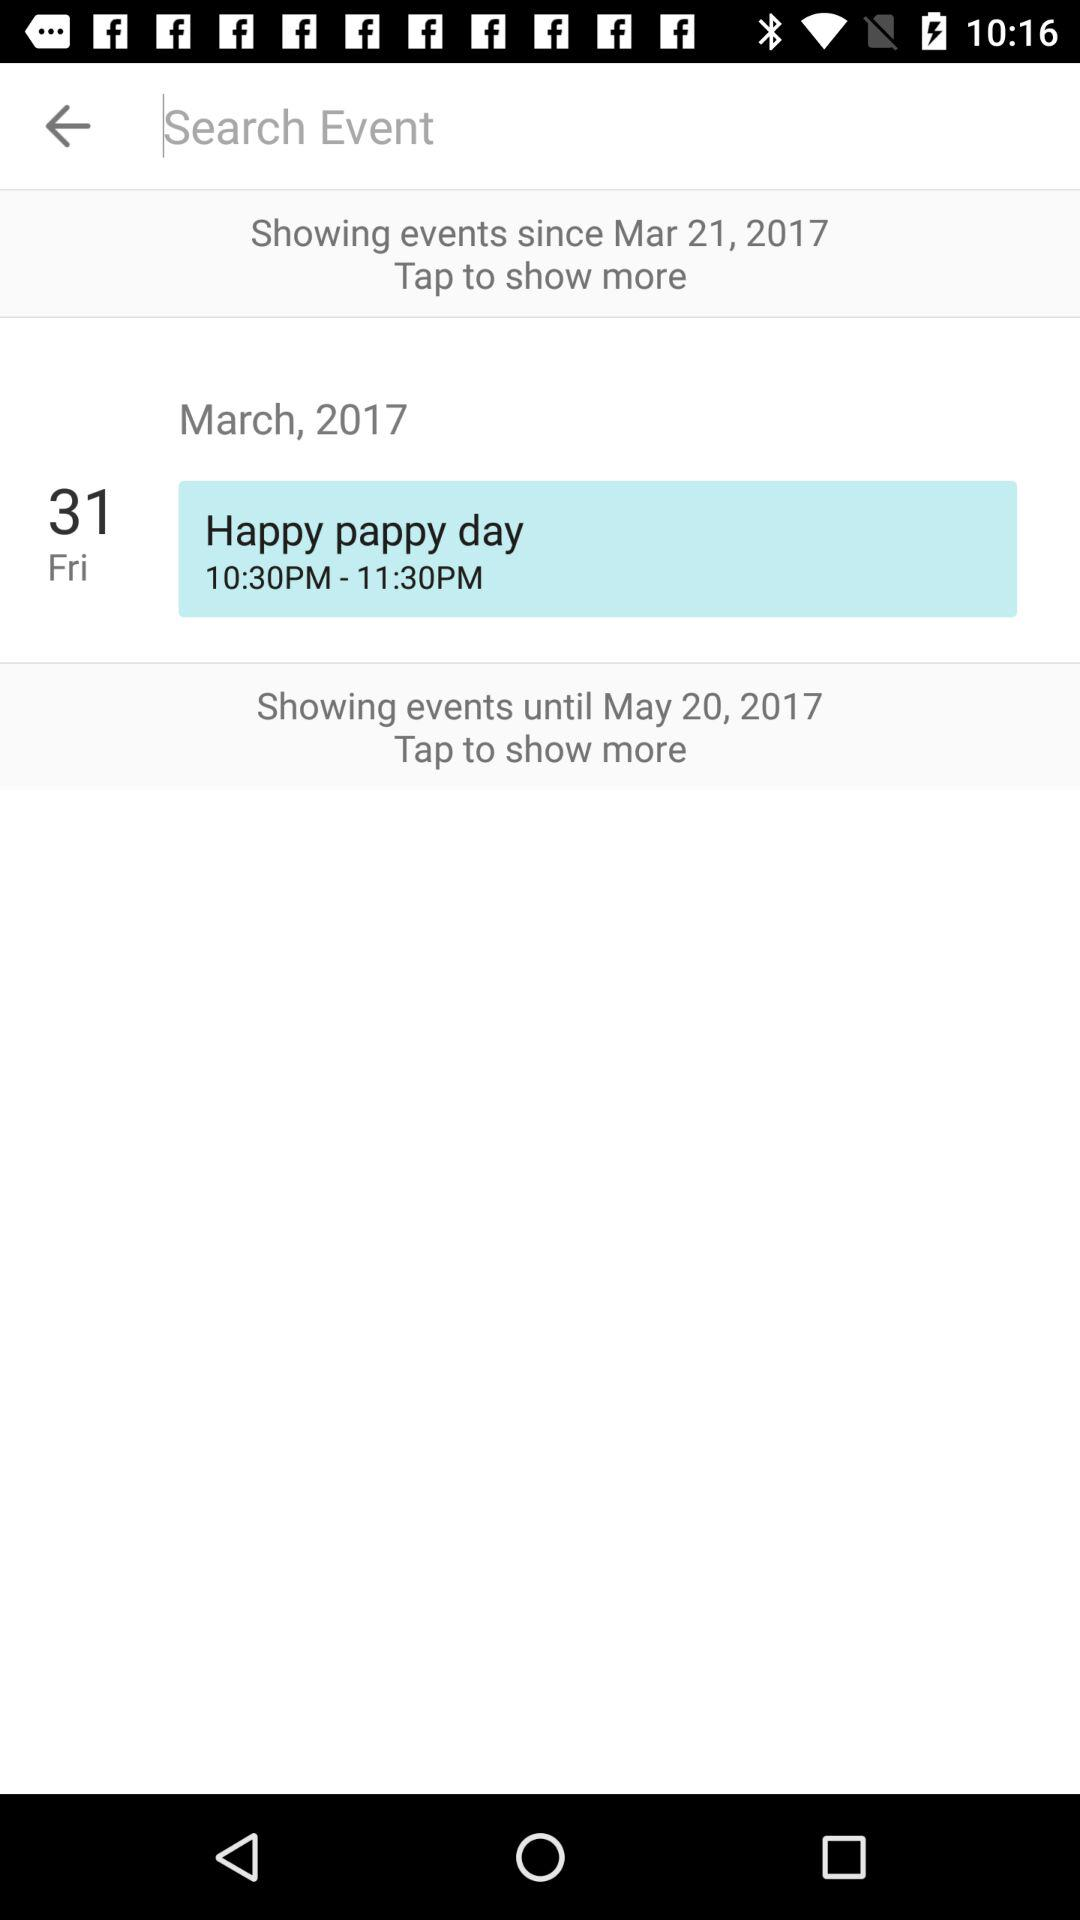What is the date for Happy Pappy Day? The date for Happy Pappy Day is Friday, March 31, 2017. 